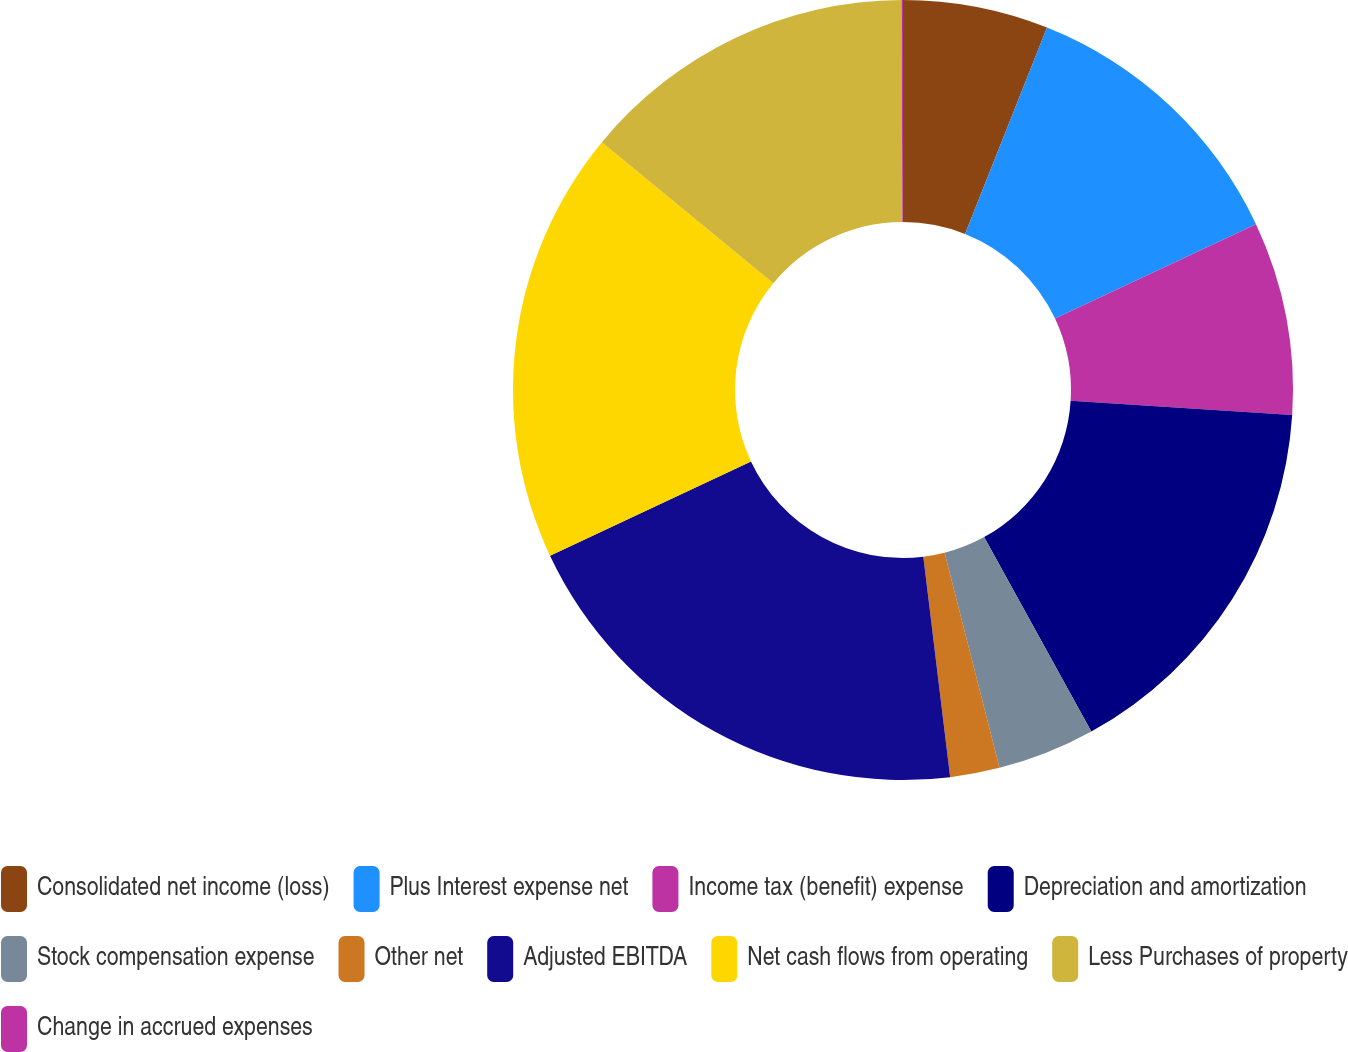Convert chart to OTSL. <chart><loc_0><loc_0><loc_500><loc_500><pie_chart><fcel>Consolidated net income (loss)<fcel>Plus Interest expense net<fcel>Income tax (benefit) expense<fcel>Depreciation and amortization<fcel>Stock compensation expense<fcel>Other net<fcel>Adjusted EBITDA<fcel>Net cash flows from operating<fcel>Less Purchases of property<fcel>Change in accrued expenses<nl><fcel>6.02%<fcel>11.99%<fcel>8.01%<fcel>15.96%<fcel>4.04%<fcel>2.05%<fcel>19.94%<fcel>17.95%<fcel>13.98%<fcel>0.06%<nl></chart> 